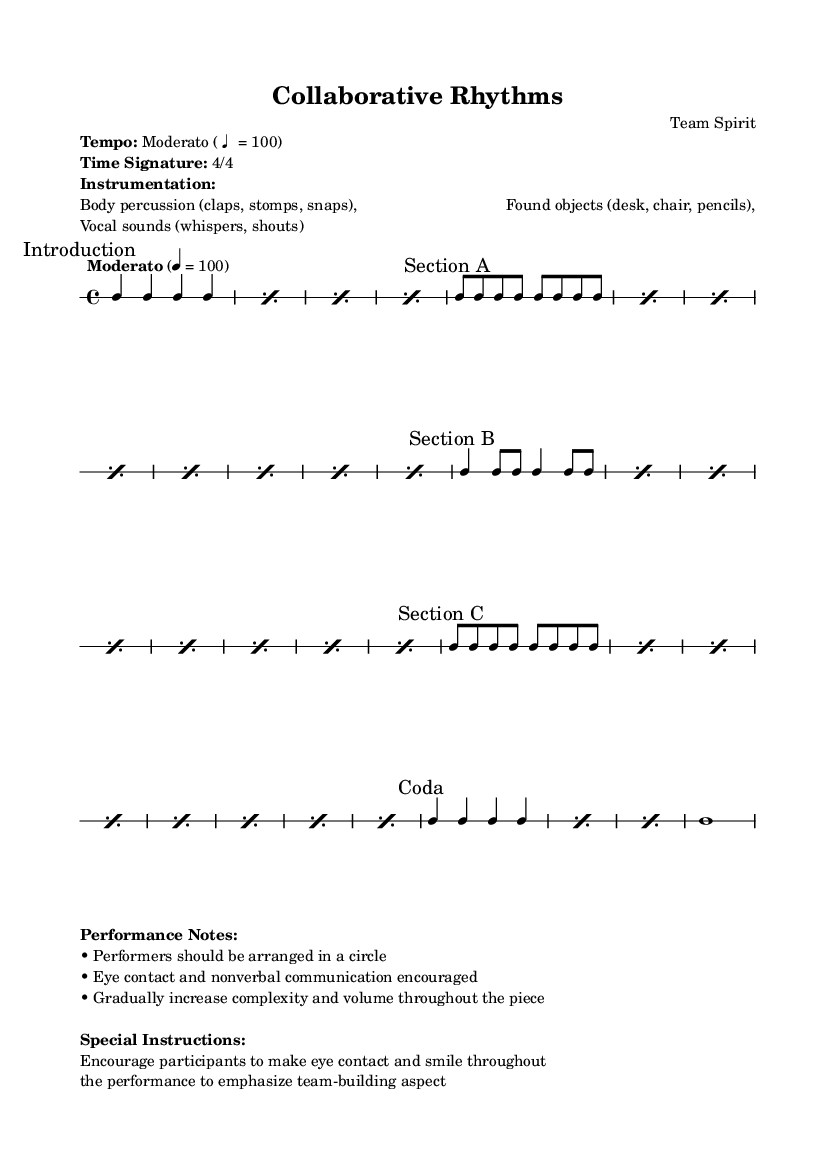What is the time signature of this music? The time signature is indicated at the beginning of the music and shows the structure of each measure. It reads 4/4, which means there are four beats per measure, and the quarter note gets one beat.
Answer: 4/4 What is the tempo marking given in the score? The tempo marking is shown in the score under the tempo instruction. It specifies “Moderato” at a speed of 100 beats per minute.
Answer: Moderato (♩ = 100) How many sections are there in this piece? By examining the markings provided throughout the score, it's clear that there are sections labeled Introduction, Section A, Section B, Section C, and Coda, totaling five distinct sections.
Answer: 5 What types of instrumentation are mentioned in the performance notes? The performance notes list specific types of instrumentation. It mentions body percussion, found objects, and vocal sounds, indicating a variety of unconventional instruments used.
Answer: Body percussion, found objects, vocal sounds What is the primary goal of the performance as indicated in the special instructions? The special instructions emphasize the importance of eye contact and smiling among participants during the performance, which is aimed at enhancing the team-building aspect of the activity.
Answer: Team-building What is the pattern of the repetition in Section A? In Section A, the score instructs to repeat a certain pattern eight times. The pattern is comprised of eight consecutive eighth notes, which creates a rhythmic flow that engages the performers.
Answer: c8 c c c c c c c How many measures are present in the Coda section? The Coda section instructs to repeat a specific pattern three times and then ends with a single long note, indicating that it comprises four measures in total when counting each repeated instance and the final note.
Answer: 4 